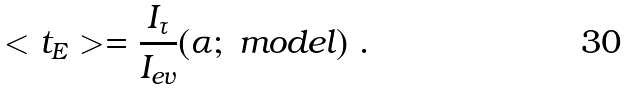<formula> <loc_0><loc_0><loc_500><loc_500>< t _ { E } > = \frac { I _ { \tau } } { I _ { e v } } ( \alpha ; \ m o d e l ) \ .</formula> 